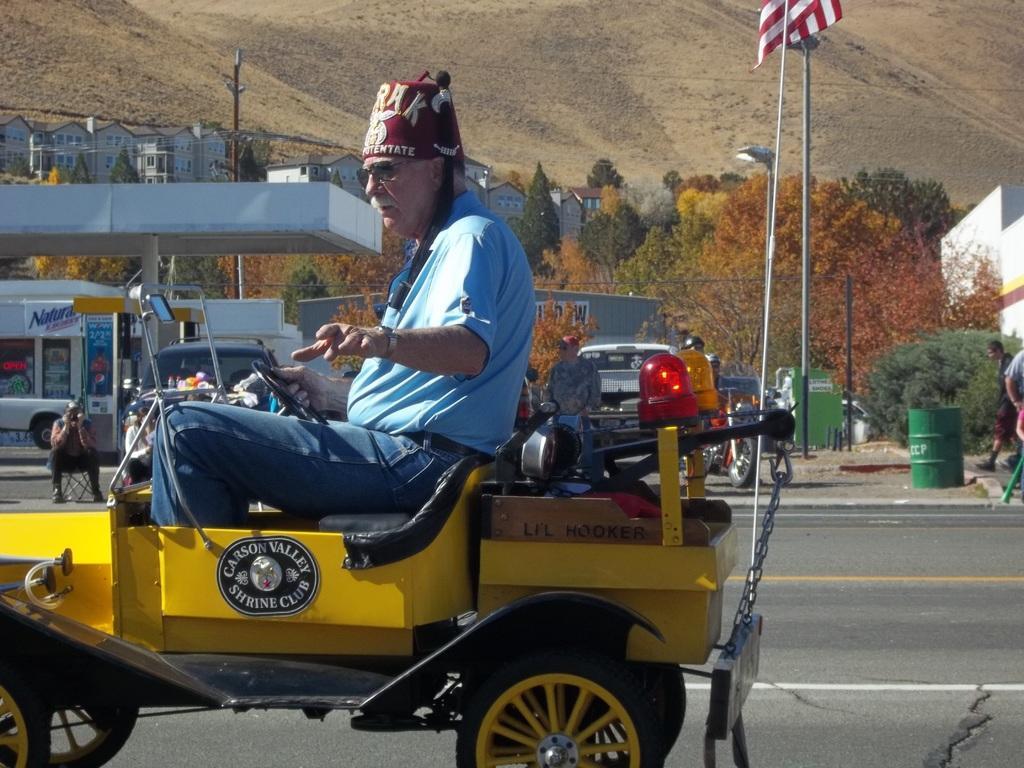Could you give a brief overview of what you see in this image? In this picture outside of the city. There is a group of people. In the center we have a person. He is sitting on a vehicle. He is wearing a cap. We can see in background trees,buildings,vehicles. 